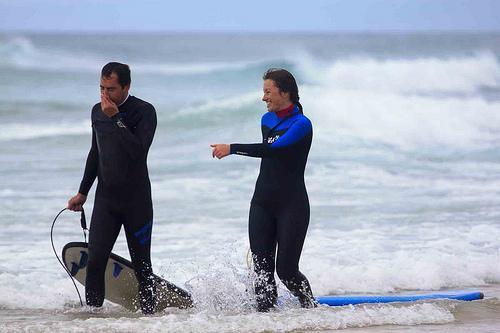How many people are in the photo?
Give a very brief answer. 2. 